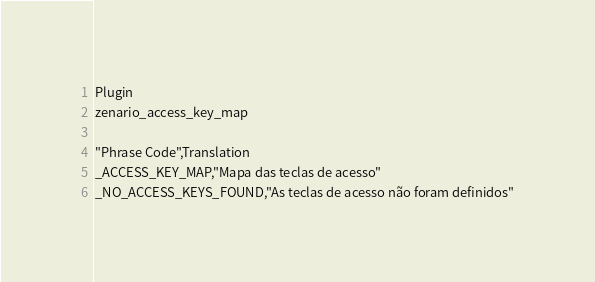Convert code to text. <code><loc_0><loc_0><loc_500><loc_500><_PHP_>Plugin
zenario_access_key_map

"Phrase Code",Translation
_ACCESS_KEY_MAP,"Mapa das teclas de acesso"
_NO_ACCESS_KEYS_FOUND,"As teclas de acesso não foram definidos"

</code> 